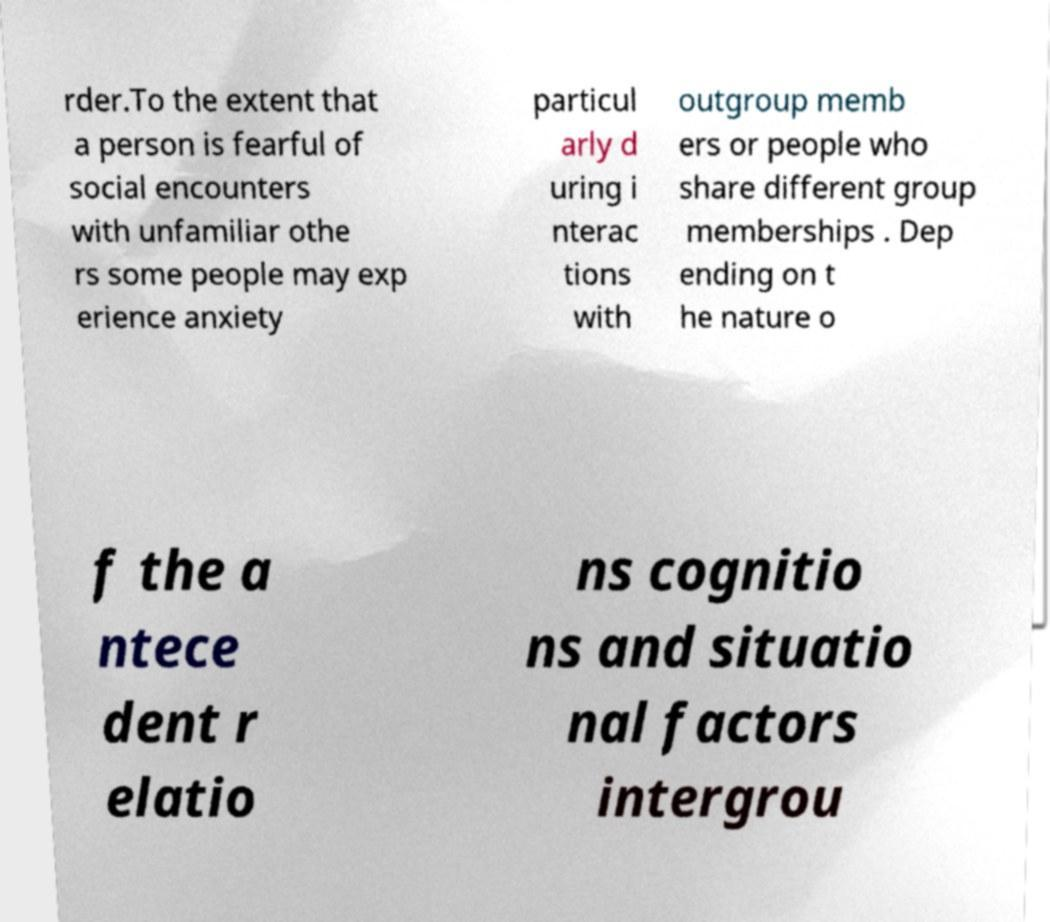Could you assist in decoding the text presented in this image and type it out clearly? rder.To the extent that a person is fearful of social encounters with unfamiliar othe rs some people may exp erience anxiety particul arly d uring i nterac tions with outgroup memb ers or people who share different group memberships . Dep ending on t he nature o f the a ntece dent r elatio ns cognitio ns and situatio nal factors intergrou 